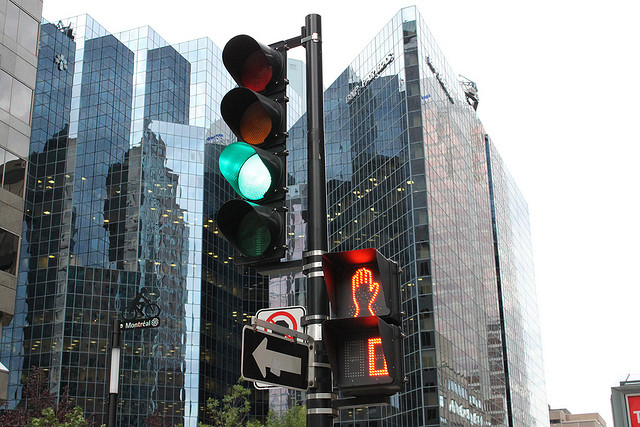Describe the surrounding architecture reflected in the building's facade. The buildings reflected on the glass facade have a modern architectural style, with clean lines, extensive use of glass, and a combination of reflective and opaque surfaces. Their design contributes to the sleek urban look of the cityscape. 